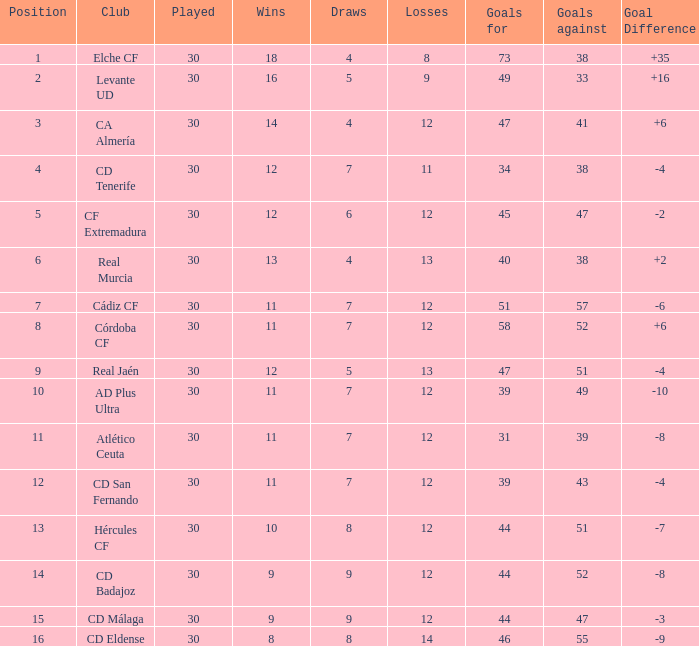What is the number of goals with less than 14 wins and a goal difference less than -4? 51, 39, 31, 44, 44, 46. 